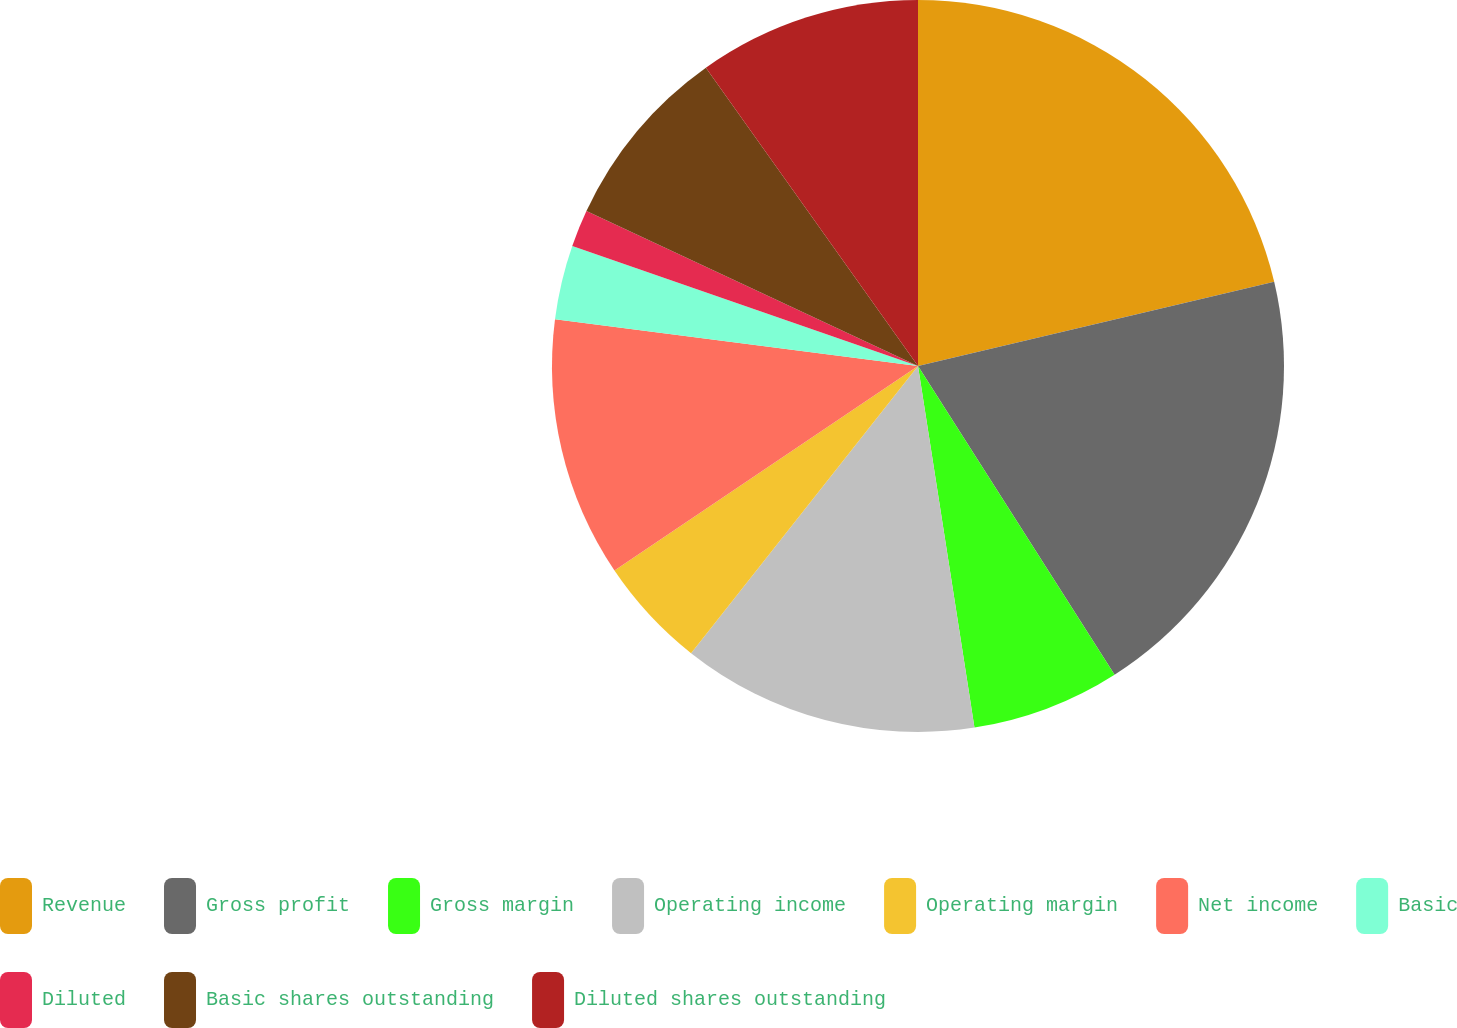Convert chart to OTSL. <chart><loc_0><loc_0><loc_500><loc_500><pie_chart><fcel>Revenue<fcel>Gross profit<fcel>Gross margin<fcel>Operating income<fcel>Operating margin<fcel>Net income<fcel>Basic<fcel>Diluted<fcel>Basic shares outstanding<fcel>Diluted shares outstanding<nl><fcel>21.31%<fcel>19.67%<fcel>6.56%<fcel>13.11%<fcel>4.92%<fcel>11.48%<fcel>3.28%<fcel>1.64%<fcel>8.2%<fcel>9.84%<nl></chart> 